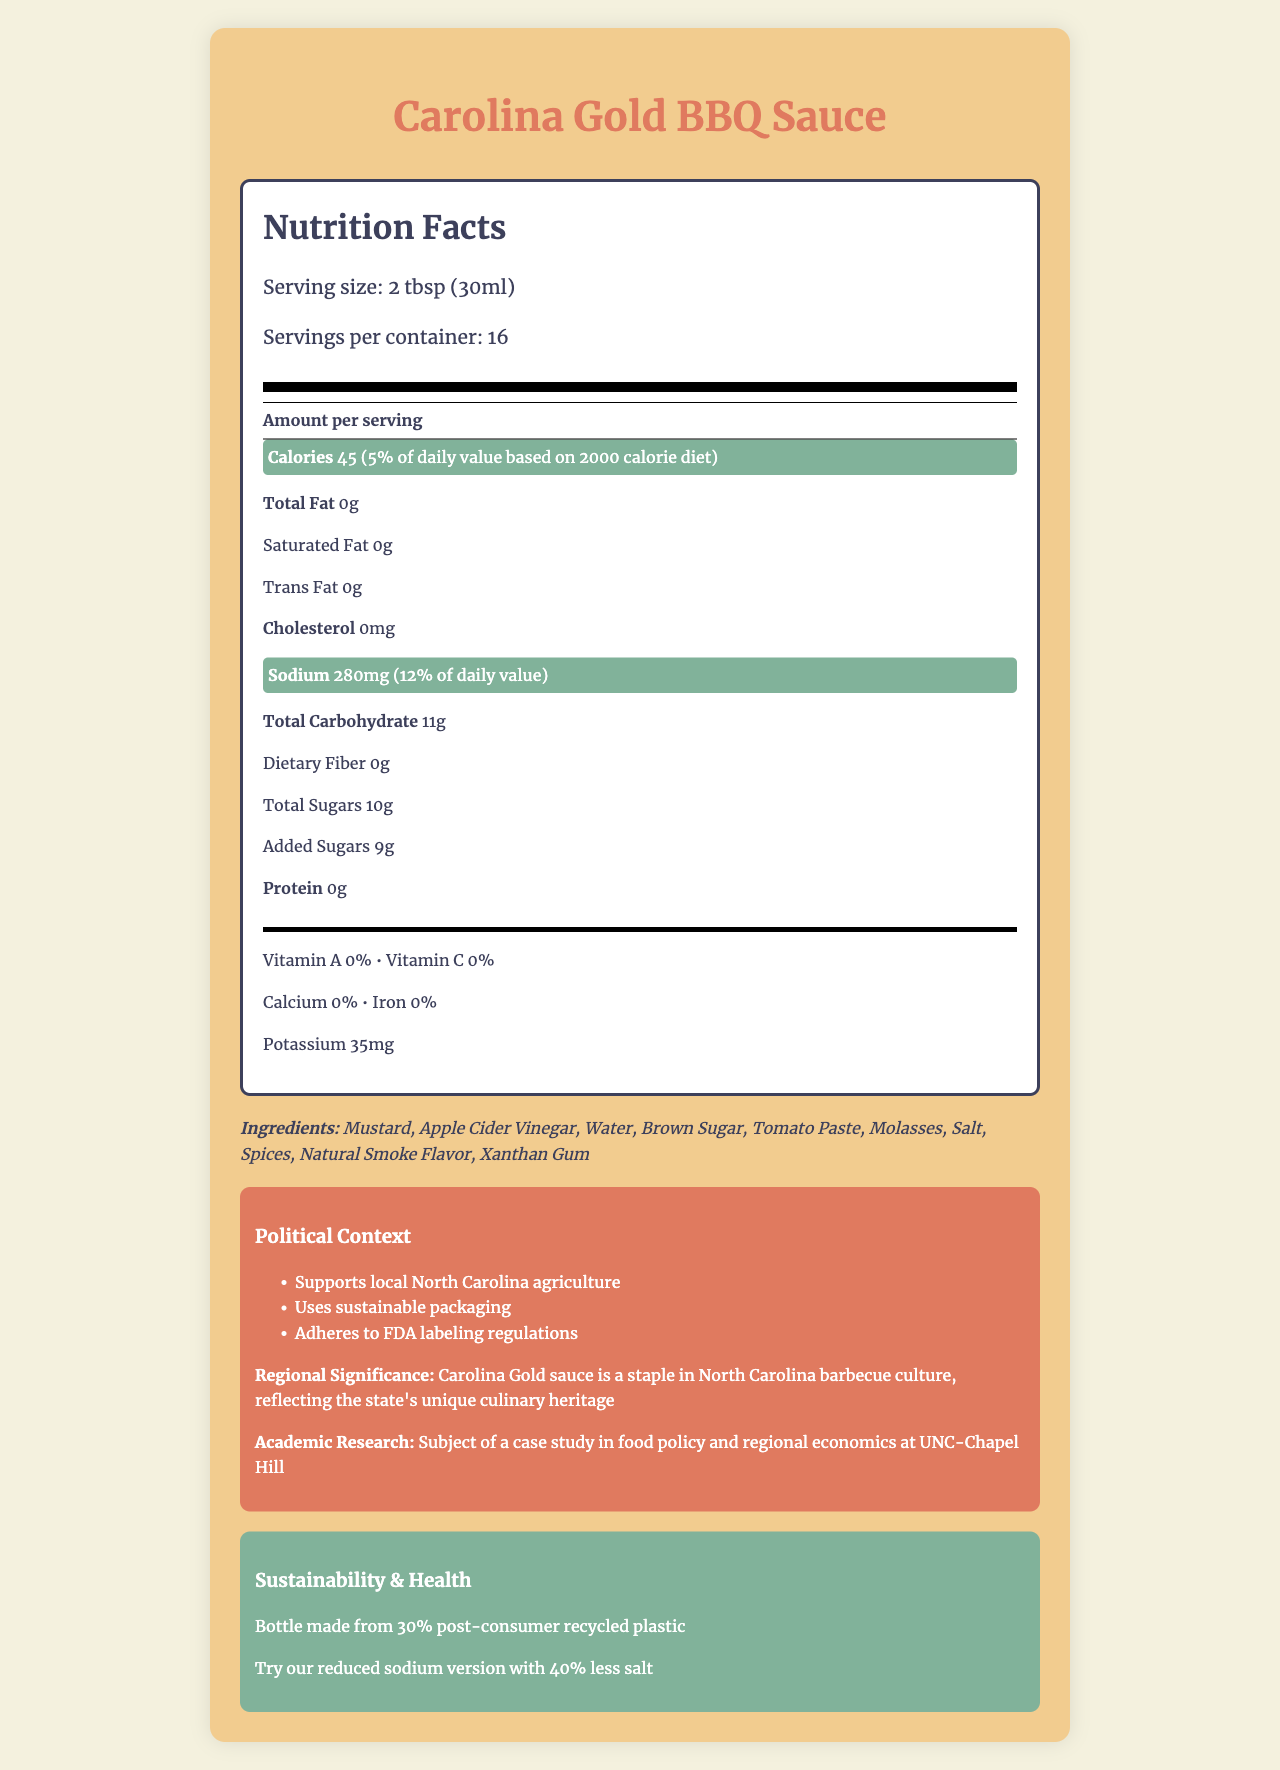what is the serving size of Carolina Gold BBQ Sauce? The serving size is explicitly listed as "2 tbsp (30ml)" in the document under serving information.
Answer: 2 tbsp (30ml) how many calories are there per serving of the sauce? The document highlights that each serving contains 45 calories.
Answer: 45 how much sodium is in one serving, and what percentage of the daily value does this represent? The sodium content is highlighted as 280mg, and it represents 12% of the daily value.
Answer: 280mg, 12% what are the main ingredients in Carolina Gold BBQ Sauce? These ingredients are listed in the ingredients section of the document.
Answer: Mustard, Apple Cider Vinegar, Water, Brown Sugar, Tomato Paste, Molasses, Salt, Spices, Natural Smoke Flavor, Xanthan Gum how many servings are there in one container of the sauce? The document states that there are 16 servings per container.
Answer: 16 which of the following is not listed as an ingredient in the sauce? A. Molasses B. Honey C. Brown Sugar D. Tomato Paste Honey is not listed among the ingredients, whereas Molasses, Brown Sugar, and Tomato Paste are.
Answer: B what is the protein content per serving? A. 0g B. 2g C. 5g D. 10g The document specifies that the protein content per serving is 0g.
Answer: A is the statement "the sauce contains gluten" true? The allergens section states "None," indicating that the sauce does not contain gluten.
Answer: No summarize the main highlights of the Carolina Gold BBQ Sauce nutrition label and additional details. The document provides nutrition details, ingredient lists, and highlights the sauce's political, regional, and sustainability context. It emphasizes the low-fat content and sustainable practices of the product.
Answer: The Carolina Gold BBQ Sauce has 45 calories and 280mg of sodium per serving. It is low in fat and includes ingredients like mustard, apple cider vinegar, and brown sugar. The sauce uses sustainable packaging, supports local agriculture in North Carolina, and adheres to FDA regulations. what is the cholesterol content in the sauce? The nutrition label lists the cholesterol content per serving as 0mg.
Answer: 0mg who manufactures the sauce, and where is it produced? The document states that the sauce is manufactured by Tar Heel Sauces, LLC in Chapel Hill, NC.
Answer: Tar Heel Sauces, LLC, Chapel Hill, NC is there any information about Vitamin D content in the sauce? The nutrition label does not provide any information about Vitamin D content.
Answer: No what sustainable practice is mentioned regarding the sauce's packaging? This information is provided in the sustainability note section.
Answer: The bottle is made from 30% post-consumer recycled plastic. compare the amount of total sugars and added sugars per serving. The nutrition label specifies that each serving contains 10g of total sugars, out of which 9g are added sugars.
Answer: Total Sugars: 10g, Added Sugars: 9g what academic research is the sauce a subject of? The political context notes mention that the sauce is the subject of a case study at UNC-Chapel Hill.
Answer: A case study in food policy and regional economics at UNC-Chapel Hill what percentage of the daily value of calcium does the sauce provide? The document states that the sauce provides 0% of the daily value of calcium.
Answer: 0% does the sauce support any local initiatives? The document notes that the sauce "supports local North Carolina agriculture".
Answer: Yes 